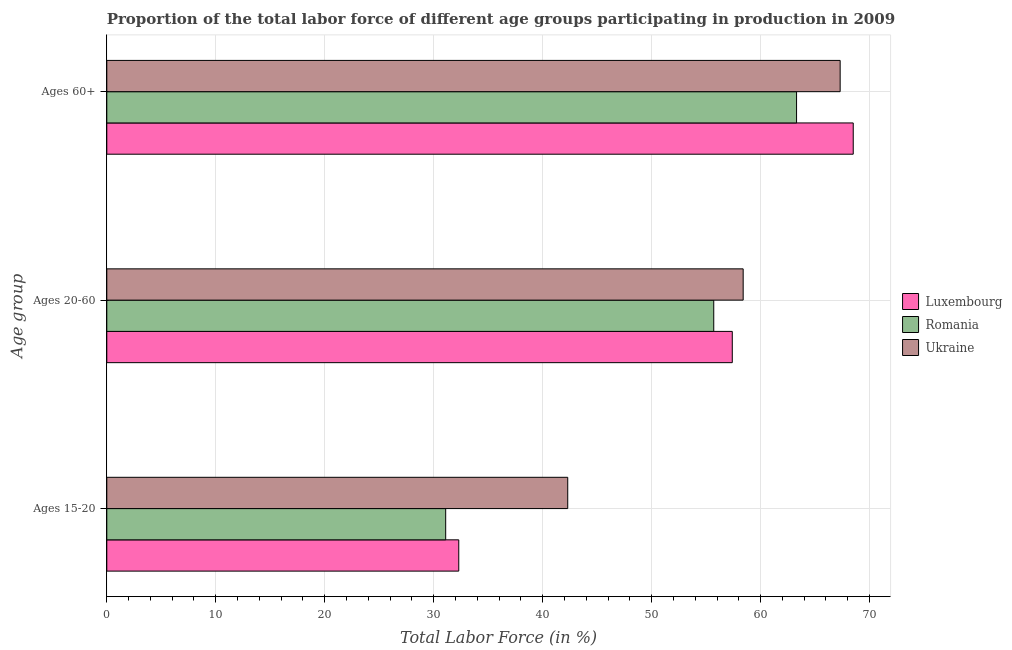How many different coloured bars are there?
Provide a succinct answer. 3. Are the number of bars per tick equal to the number of legend labels?
Give a very brief answer. Yes. Are the number of bars on each tick of the Y-axis equal?
Offer a very short reply. Yes. How many bars are there on the 2nd tick from the top?
Offer a very short reply. 3. How many bars are there on the 2nd tick from the bottom?
Ensure brevity in your answer.  3. What is the label of the 3rd group of bars from the top?
Your response must be concise. Ages 15-20. What is the percentage of labor force within the age group 15-20 in Luxembourg?
Provide a succinct answer. 32.3. Across all countries, what is the maximum percentage of labor force within the age group 20-60?
Give a very brief answer. 58.4. Across all countries, what is the minimum percentage of labor force above age 60?
Make the answer very short. 63.3. In which country was the percentage of labor force above age 60 maximum?
Ensure brevity in your answer.  Luxembourg. In which country was the percentage of labor force above age 60 minimum?
Provide a short and direct response. Romania. What is the total percentage of labor force within the age group 15-20 in the graph?
Give a very brief answer. 105.7. What is the difference between the percentage of labor force within the age group 20-60 in Ukraine and that in Romania?
Your response must be concise. 2.7. What is the difference between the percentage of labor force within the age group 20-60 in Luxembourg and the percentage of labor force above age 60 in Ukraine?
Give a very brief answer. -9.9. What is the average percentage of labor force within the age group 20-60 per country?
Make the answer very short. 57.17. What is the difference between the percentage of labor force above age 60 and percentage of labor force within the age group 15-20 in Romania?
Offer a very short reply. 32.2. In how many countries, is the percentage of labor force within the age group 20-60 greater than 64 %?
Your response must be concise. 0. What is the ratio of the percentage of labor force within the age group 15-20 in Ukraine to that in Romania?
Make the answer very short. 1.36. Is the percentage of labor force within the age group 15-20 in Ukraine less than that in Romania?
Provide a short and direct response. No. What is the difference between the highest and the second highest percentage of labor force above age 60?
Ensure brevity in your answer.  1.2. What is the difference between the highest and the lowest percentage of labor force within the age group 15-20?
Give a very brief answer. 11.2. In how many countries, is the percentage of labor force within the age group 15-20 greater than the average percentage of labor force within the age group 15-20 taken over all countries?
Provide a succinct answer. 1. What does the 3rd bar from the top in Ages 15-20 represents?
Make the answer very short. Luxembourg. What does the 2nd bar from the bottom in Ages 60+ represents?
Your answer should be compact. Romania. Is it the case that in every country, the sum of the percentage of labor force within the age group 15-20 and percentage of labor force within the age group 20-60 is greater than the percentage of labor force above age 60?
Your answer should be compact. Yes. Are all the bars in the graph horizontal?
Provide a short and direct response. Yes. How many countries are there in the graph?
Keep it short and to the point. 3. What is the difference between two consecutive major ticks on the X-axis?
Give a very brief answer. 10. Does the graph contain any zero values?
Your answer should be very brief. No. Where does the legend appear in the graph?
Make the answer very short. Center right. How many legend labels are there?
Provide a short and direct response. 3. What is the title of the graph?
Your answer should be compact. Proportion of the total labor force of different age groups participating in production in 2009. What is the label or title of the Y-axis?
Your answer should be compact. Age group. What is the Total Labor Force (in %) of Luxembourg in Ages 15-20?
Your response must be concise. 32.3. What is the Total Labor Force (in %) of Romania in Ages 15-20?
Your answer should be very brief. 31.1. What is the Total Labor Force (in %) of Ukraine in Ages 15-20?
Offer a terse response. 42.3. What is the Total Labor Force (in %) in Luxembourg in Ages 20-60?
Keep it short and to the point. 57.4. What is the Total Labor Force (in %) in Romania in Ages 20-60?
Your answer should be compact. 55.7. What is the Total Labor Force (in %) of Ukraine in Ages 20-60?
Your answer should be very brief. 58.4. What is the Total Labor Force (in %) of Luxembourg in Ages 60+?
Your response must be concise. 68.5. What is the Total Labor Force (in %) of Romania in Ages 60+?
Offer a terse response. 63.3. What is the Total Labor Force (in %) of Ukraine in Ages 60+?
Your answer should be compact. 67.3. Across all Age group, what is the maximum Total Labor Force (in %) in Luxembourg?
Provide a short and direct response. 68.5. Across all Age group, what is the maximum Total Labor Force (in %) in Romania?
Provide a succinct answer. 63.3. Across all Age group, what is the maximum Total Labor Force (in %) in Ukraine?
Make the answer very short. 67.3. Across all Age group, what is the minimum Total Labor Force (in %) of Luxembourg?
Your answer should be very brief. 32.3. Across all Age group, what is the minimum Total Labor Force (in %) of Romania?
Your answer should be compact. 31.1. Across all Age group, what is the minimum Total Labor Force (in %) of Ukraine?
Ensure brevity in your answer.  42.3. What is the total Total Labor Force (in %) in Luxembourg in the graph?
Offer a terse response. 158.2. What is the total Total Labor Force (in %) in Romania in the graph?
Give a very brief answer. 150.1. What is the total Total Labor Force (in %) in Ukraine in the graph?
Make the answer very short. 168. What is the difference between the Total Labor Force (in %) in Luxembourg in Ages 15-20 and that in Ages 20-60?
Provide a succinct answer. -25.1. What is the difference between the Total Labor Force (in %) in Romania in Ages 15-20 and that in Ages 20-60?
Offer a very short reply. -24.6. What is the difference between the Total Labor Force (in %) in Ukraine in Ages 15-20 and that in Ages 20-60?
Offer a terse response. -16.1. What is the difference between the Total Labor Force (in %) of Luxembourg in Ages 15-20 and that in Ages 60+?
Make the answer very short. -36.2. What is the difference between the Total Labor Force (in %) of Romania in Ages 15-20 and that in Ages 60+?
Provide a short and direct response. -32.2. What is the difference between the Total Labor Force (in %) in Ukraine in Ages 15-20 and that in Ages 60+?
Make the answer very short. -25. What is the difference between the Total Labor Force (in %) of Luxembourg in Ages 20-60 and that in Ages 60+?
Your answer should be very brief. -11.1. What is the difference between the Total Labor Force (in %) of Ukraine in Ages 20-60 and that in Ages 60+?
Your response must be concise. -8.9. What is the difference between the Total Labor Force (in %) of Luxembourg in Ages 15-20 and the Total Labor Force (in %) of Romania in Ages 20-60?
Provide a short and direct response. -23.4. What is the difference between the Total Labor Force (in %) in Luxembourg in Ages 15-20 and the Total Labor Force (in %) in Ukraine in Ages 20-60?
Your answer should be very brief. -26.1. What is the difference between the Total Labor Force (in %) in Romania in Ages 15-20 and the Total Labor Force (in %) in Ukraine in Ages 20-60?
Your answer should be compact. -27.3. What is the difference between the Total Labor Force (in %) of Luxembourg in Ages 15-20 and the Total Labor Force (in %) of Romania in Ages 60+?
Ensure brevity in your answer.  -31. What is the difference between the Total Labor Force (in %) of Luxembourg in Ages 15-20 and the Total Labor Force (in %) of Ukraine in Ages 60+?
Provide a short and direct response. -35. What is the difference between the Total Labor Force (in %) of Romania in Ages 15-20 and the Total Labor Force (in %) of Ukraine in Ages 60+?
Give a very brief answer. -36.2. What is the difference between the Total Labor Force (in %) in Luxembourg in Ages 20-60 and the Total Labor Force (in %) in Ukraine in Ages 60+?
Your answer should be compact. -9.9. What is the average Total Labor Force (in %) in Luxembourg per Age group?
Offer a terse response. 52.73. What is the average Total Labor Force (in %) in Romania per Age group?
Offer a terse response. 50.03. What is the difference between the Total Labor Force (in %) of Romania and Total Labor Force (in %) of Ukraine in Ages 15-20?
Keep it short and to the point. -11.2. What is the difference between the Total Labor Force (in %) of Luxembourg and Total Labor Force (in %) of Ukraine in Ages 20-60?
Offer a terse response. -1. What is the difference between the Total Labor Force (in %) in Romania and Total Labor Force (in %) in Ukraine in Ages 20-60?
Ensure brevity in your answer.  -2.7. What is the difference between the Total Labor Force (in %) in Luxembourg and Total Labor Force (in %) in Ukraine in Ages 60+?
Provide a short and direct response. 1.2. What is the difference between the Total Labor Force (in %) of Romania and Total Labor Force (in %) of Ukraine in Ages 60+?
Your answer should be very brief. -4. What is the ratio of the Total Labor Force (in %) of Luxembourg in Ages 15-20 to that in Ages 20-60?
Give a very brief answer. 0.56. What is the ratio of the Total Labor Force (in %) of Romania in Ages 15-20 to that in Ages 20-60?
Offer a terse response. 0.56. What is the ratio of the Total Labor Force (in %) in Ukraine in Ages 15-20 to that in Ages 20-60?
Provide a succinct answer. 0.72. What is the ratio of the Total Labor Force (in %) in Luxembourg in Ages 15-20 to that in Ages 60+?
Ensure brevity in your answer.  0.47. What is the ratio of the Total Labor Force (in %) of Romania in Ages 15-20 to that in Ages 60+?
Provide a succinct answer. 0.49. What is the ratio of the Total Labor Force (in %) in Ukraine in Ages 15-20 to that in Ages 60+?
Offer a terse response. 0.63. What is the ratio of the Total Labor Force (in %) of Luxembourg in Ages 20-60 to that in Ages 60+?
Provide a short and direct response. 0.84. What is the ratio of the Total Labor Force (in %) in Romania in Ages 20-60 to that in Ages 60+?
Your response must be concise. 0.88. What is the ratio of the Total Labor Force (in %) of Ukraine in Ages 20-60 to that in Ages 60+?
Provide a succinct answer. 0.87. What is the difference between the highest and the second highest Total Labor Force (in %) in Romania?
Ensure brevity in your answer.  7.6. What is the difference between the highest and the lowest Total Labor Force (in %) of Luxembourg?
Give a very brief answer. 36.2. What is the difference between the highest and the lowest Total Labor Force (in %) of Romania?
Make the answer very short. 32.2. What is the difference between the highest and the lowest Total Labor Force (in %) of Ukraine?
Your answer should be compact. 25. 